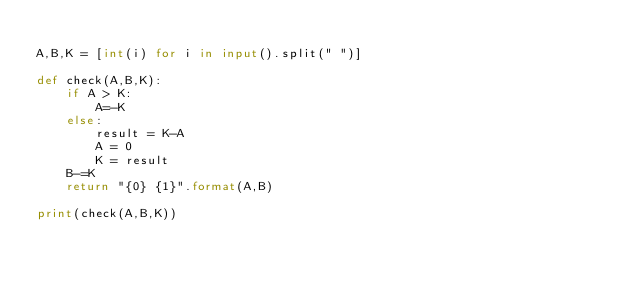Convert code to text. <code><loc_0><loc_0><loc_500><loc_500><_Python_>
A,B,K = [int(i) for i in input().split(" ")]

def check(A,B,K):
    if A > K:
        A=-K
    else:
        result = K-A
        A = 0
        K = result
    B-=K
    return "{0} {1}".format(A,B)

print(check(A,B,K))</code> 